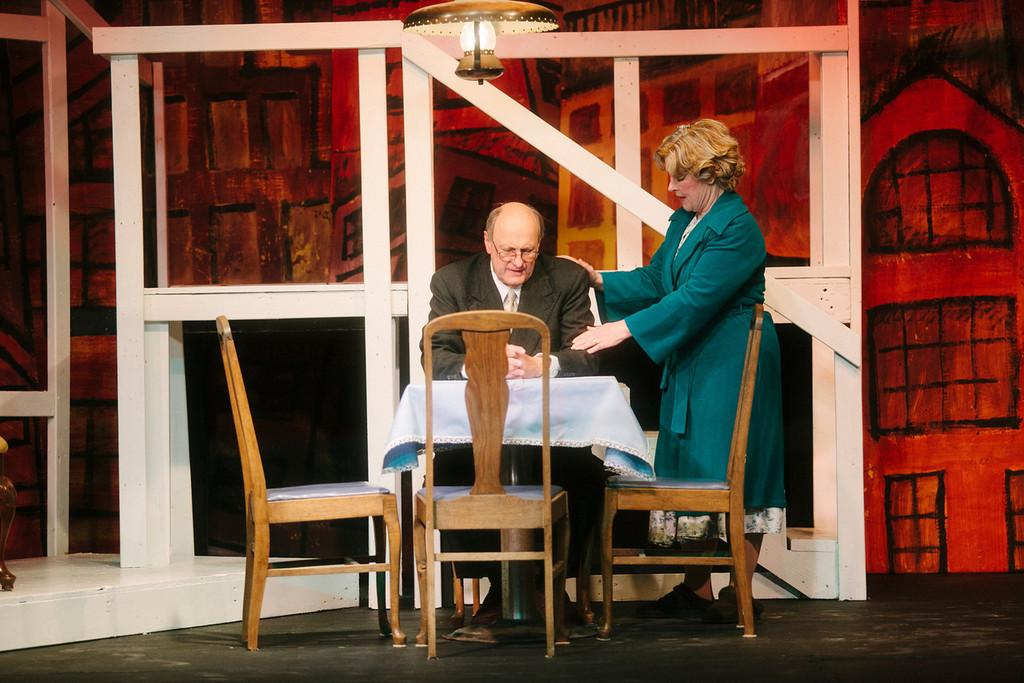How many people are in the image? There are two people in the image. Can you describe the positions of the people? One person, a man, is sitting, and the other person, a woman, is standing. What furniture is present in the image? There is a table and chairs in the image. What is located above the table and chairs? There is a lamp above the table and chairs. What type of pet can be seen sitting next to the man in the image? There is no pet present in the image; only the man, the woman, the table, the chairs, and the lamp are visible. 